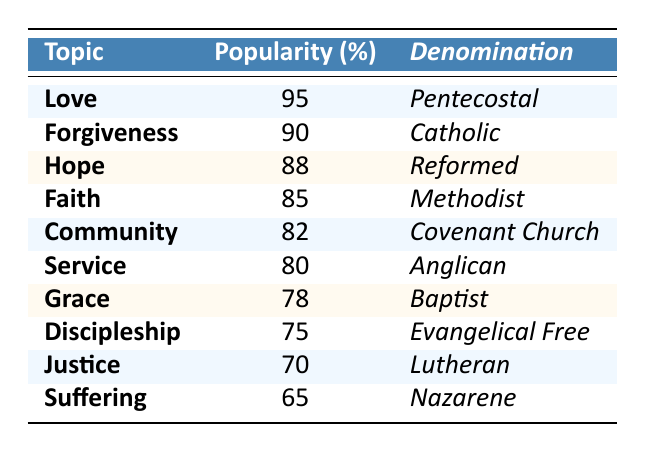What is the most popular topic among parishioners in 2023? The table shows that the topic with the highest popularity percentage is "Love," which has a score of 95%.
Answer: Love Which denomination has the lowest popularity score for its expository preaching topic? The table indicates that the "Suffering" topic related to the Nazarene denomination has the lowest popularity at 65%.
Answer: Nazarene What is the average popularity score of all the topics listed? To find the average, sum up all popularity scores: 95 + 90 + 88 + 85 + 82 + 80 + 78 + 75 + 70 + 65 =  820. Then, divide by 10 (the number of topics): 820 / 10 = 82.
Answer: 82 Does the Catholic denomination have a topic that is more popular than the topic of "Hope"? The table shows that the Catholic topic "Forgiveness" has a popularity of 90%, which is greater than the 88% for "Hope." Therefore, the statement is true.
Answer: Yes Which two topics are most closely associated with the highest popularity scores? The two topics with the highest popularity scores are "Love" (95%) and "Forgiveness" (90%). Their score difference is 5% (95 - 90).
Answer: Love and Forgiveness What is the difference in popularity between the topics of "Justice" and "Discipleship"? The popularity of "Justice" is 70% and "Discipleship" is 75%. The difference is calculated by subtracting: 75 - 70 = 5%.
Answer: 5% Is the topic "Grace" more popular than "Community"? The popularity of "Grace" is 78% while "Community" is 82%. Since 78% is less than 82%, the statement is false.
Answer: No Which topics appear to belong to the same denomination as "Service"? Referring to the table, "Service" is associated with the Anglican denomination. Looking at the other rows, no other topics share this denomination.
Answer: None If the popularity of "Suffering" were to increase by 10%, would it then exceed "Justice"? "Suffering" has a popularity of 65%, and if it increases by 10%, it would be 75%. "Justice" has a popularity of 70%, so 75% would not exceed 70%.
Answer: No Which denomination ranks second in popularity based on the table? The second highest popularity score is for "Forgiveness" at 90%, which belongs to the Catholic denomination. Therefore, Catholic ranks second.
Answer: Catholic 